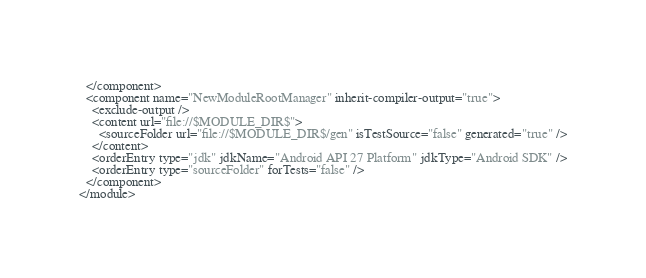Convert code to text. <code><loc_0><loc_0><loc_500><loc_500><_XML_>  </component>
  <component name="NewModuleRootManager" inherit-compiler-output="true">
    <exclude-output />
    <content url="file://$MODULE_DIR$">
      <sourceFolder url="file://$MODULE_DIR$/gen" isTestSource="false" generated="true" />
    </content>
    <orderEntry type="jdk" jdkName="Android API 27 Platform" jdkType="Android SDK" />
    <orderEntry type="sourceFolder" forTests="false" />
  </component>
</module></code> 